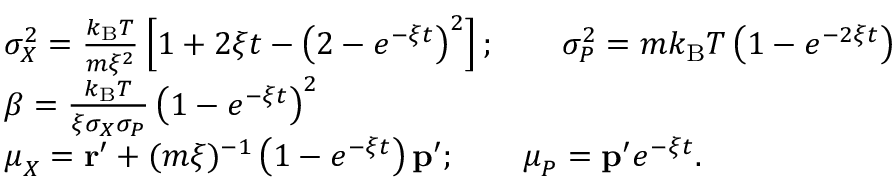<formula> <loc_0><loc_0><loc_500><loc_500>{ \begin{array} { r l } & { \sigma _ { X } ^ { 2 } = { \frac { k _ { B } T } { m \xi ^ { 2 } } } \left [ 1 + 2 \xi t - \left ( 2 - e ^ { - \xi t } \right ) ^ { 2 } \right ] ; \quad \sigma _ { P } ^ { 2 } = m k _ { B } T \left ( 1 - e ^ { - 2 \xi t } \right ) } \\ & { \beta = { \frac { k _ { B } T } { \xi \sigma _ { X } \sigma _ { P } } } \left ( 1 - e ^ { - \xi t } \right ) ^ { 2 } } \\ & { { \mu } _ { X } = r ^ { \prime } + ( m \xi ) ^ { - 1 } \left ( 1 - e ^ { - \xi t } \right ) p ^ { \prime } ; \quad { \mu } _ { P } = p ^ { \prime } e ^ { - \xi t } . } \end{array} }</formula> 